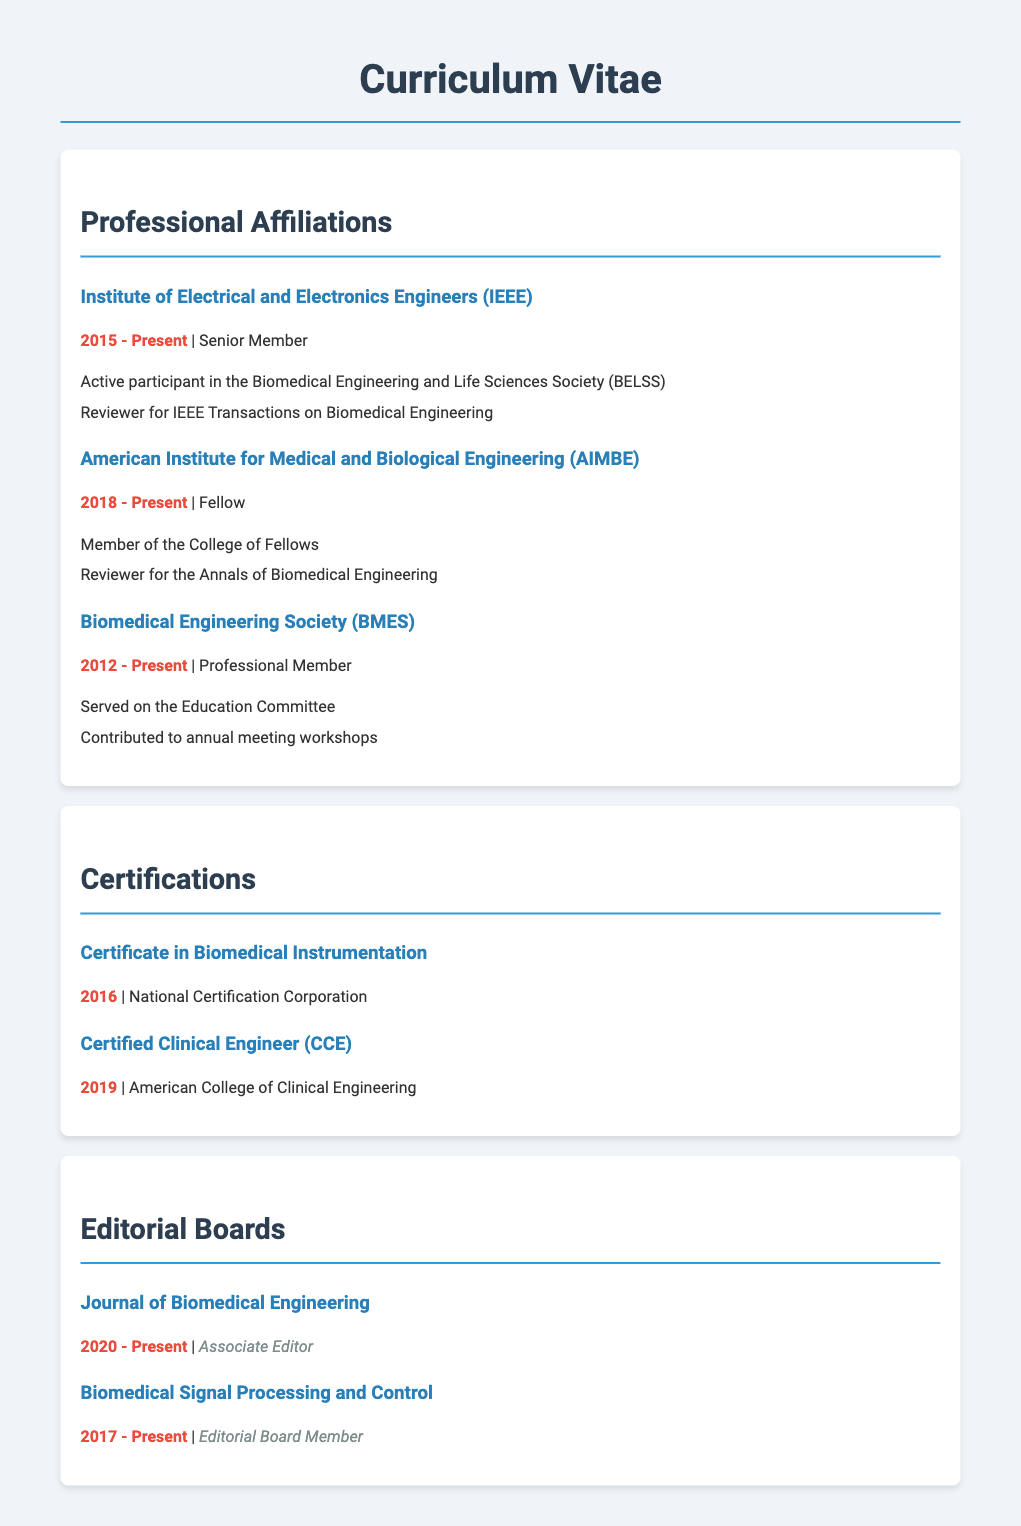what is the highest membership title held? The document lists several affiliations with specific titles, and the highest title mentioned is "Fellow" with AIMBE.
Answer: Fellow how long has the individual been a member of IEEE? The membership duration is provided in the document as from 2015 to the present, indicating the number of years involved.
Answer: 8 years which certification was obtained in 2016? The document specifies the certification acquired in 2016 as "Certificate in Biomedical Instrumentation."
Answer: Certificate in Biomedical Instrumentation what role does the individual have at the Journal of Biomedical Engineering? The document states the individual's role at this journal, which is an "Associate Editor."
Answer: Associate Editor how many organizations is the individual affiliated with? Counting through the affiliations listed in the document shows a total of three organizations.
Answer: 3 which committee did the individual serve on for the Biomedical Engineering Society? The document indicates participation in the committee responsible for "Education."
Answer: Education Committee what is the certification obtained from the American College of Clinical Engineering? The document mentions a specific certification acquired from this college, which is "Certified Clinical Engineer."
Answer: Certified Clinical Engineer For how many years has the individual been on the editorial board of Biomedical Signal Processing and Control? The duration of service mentioned in the document is from 2017 to the present, indicating how many years.
Answer: 6 years 